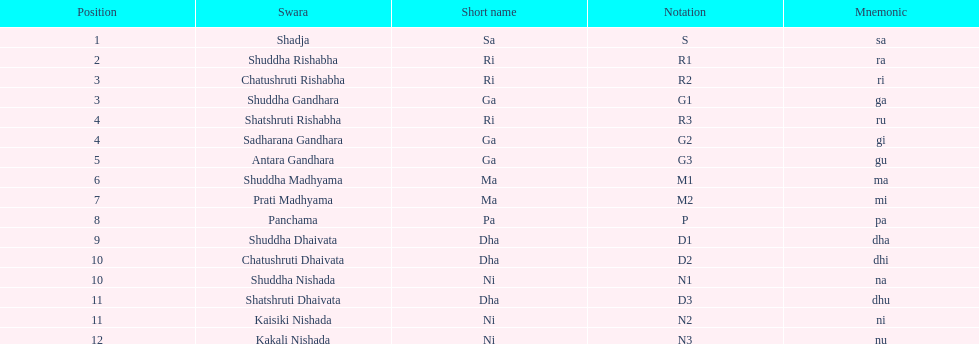How many swaras do not have dhaivata in their name? 13. 